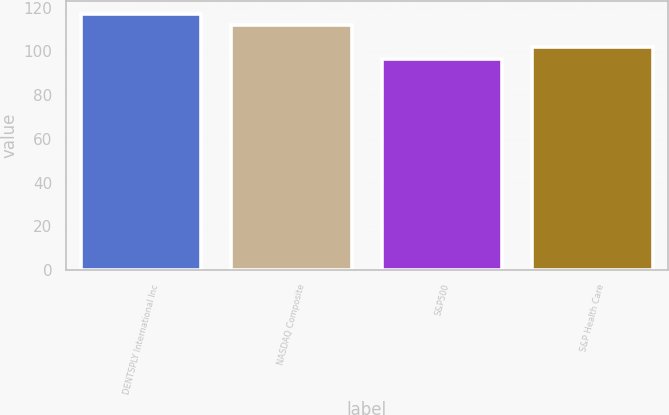<chart> <loc_0><loc_0><loc_500><loc_500><bar_chart><fcel>DENTSPLY International Inc<fcel>NASDAQ Composite<fcel>S&P500<fcel>S&P Health Care<nl><fcel>117.04<fcel>112.1<fcel>96.71<fcel>101.87<nl></chart> 